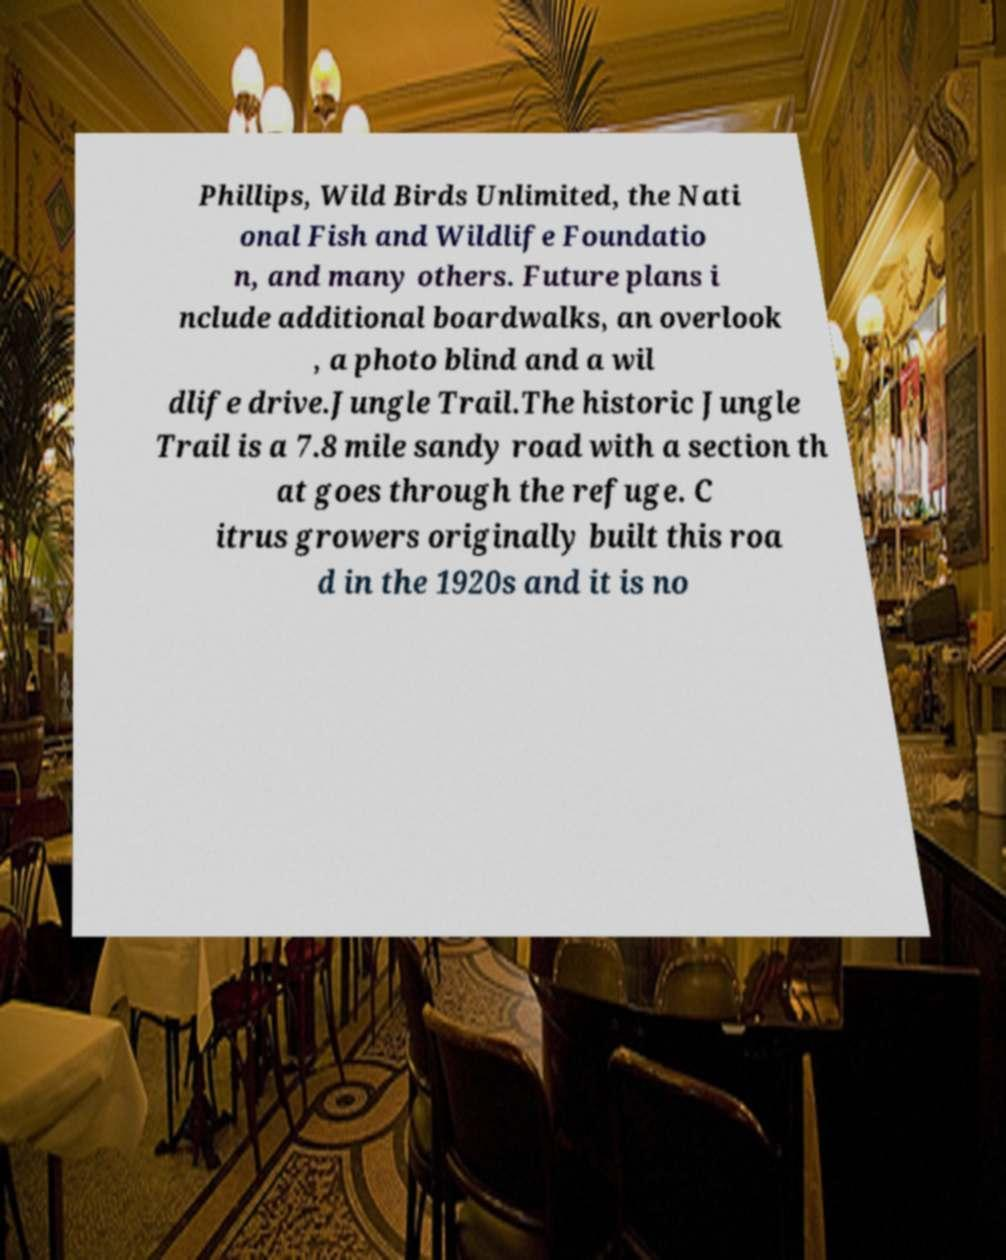What messages or text are displayed in this image? I need them in a readable, typed format. Phillips, Wild Birds Unlimited, the Nati onal Fish and Wildlife Foundatio n, and many others. Future plans i nclude additional boardwalks, an overlook , a photo blind and a wil dlife drive.Jungle Trail.The historic Jungle Trail is a 7.8 mile sandy road with a section th at goes through the refuge. C itrus growers originally built this roa d in the 1920s and it is no 